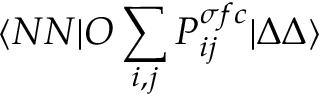Convert formula to latex. <formula><loc_0><loc_0><loc_500><loc_500>\langle N N | O \sum _ { i , j } P _ { i j } ^ { \sigma f c } | \Delta \Delta \rangle</formula> 